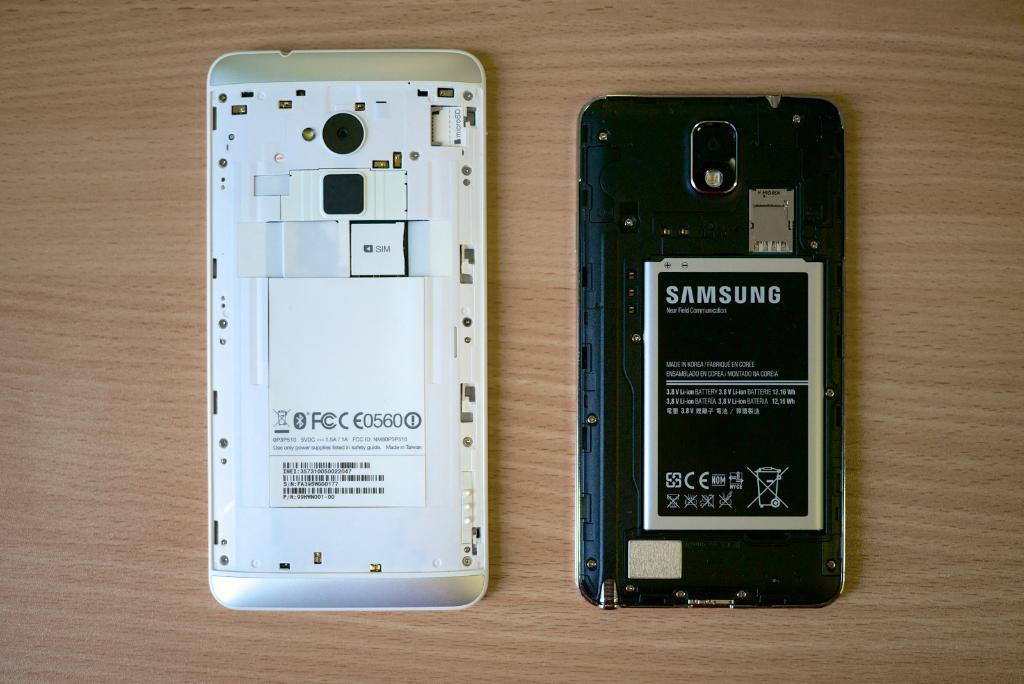<image>
Present a compact description of the photo's key features. An open old samsung phone showing the inside battery pack. 